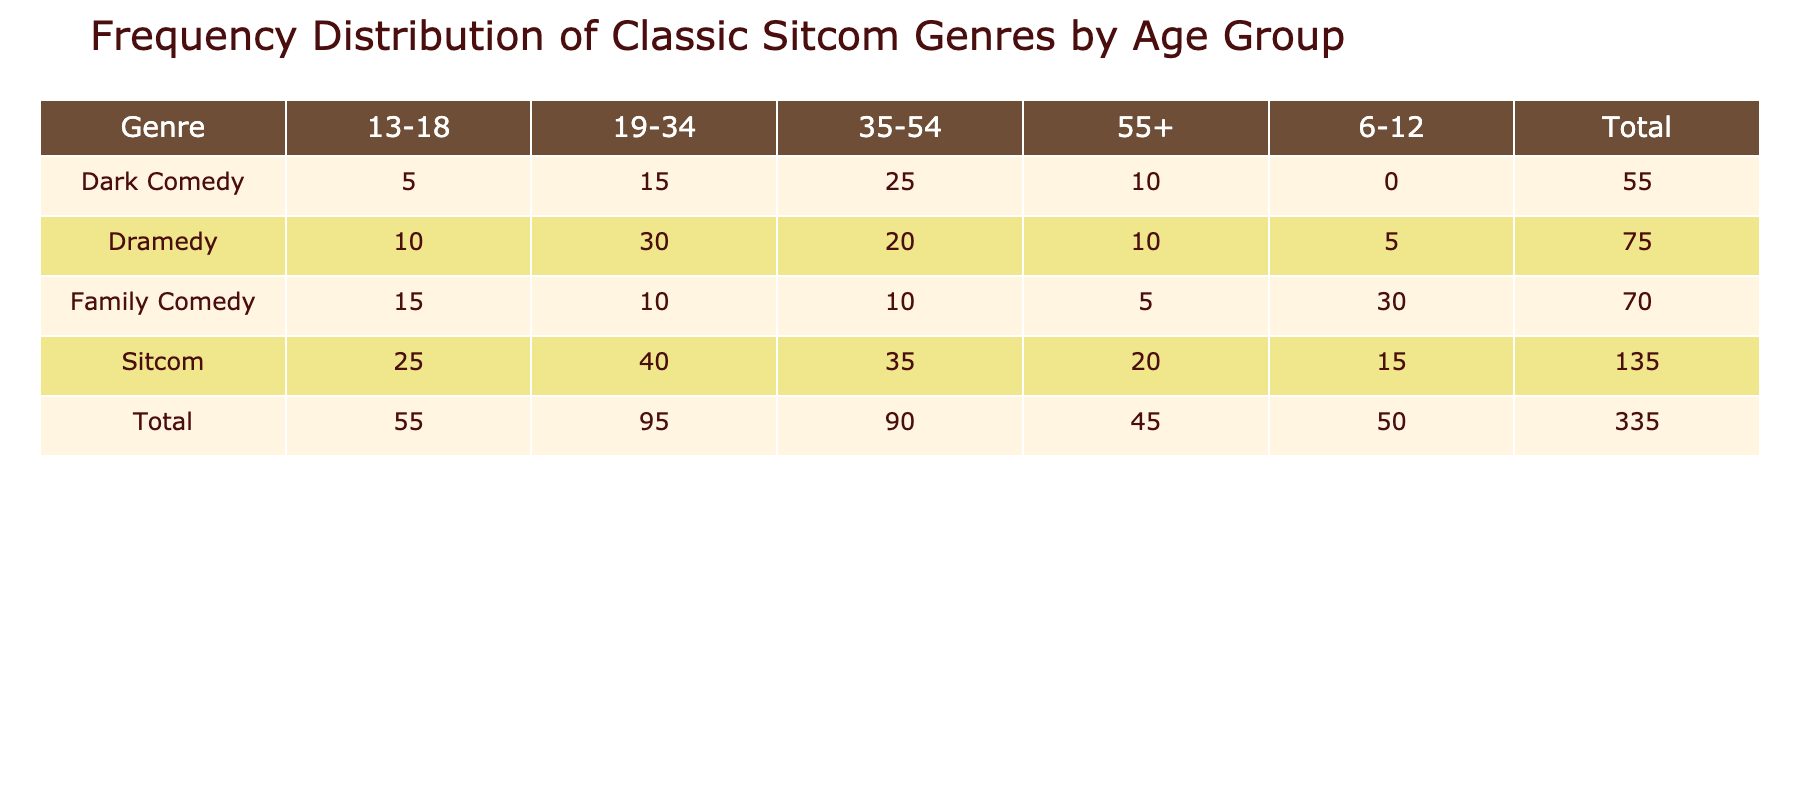What is the total frequency for the genre "Sitcom"? To find the total frequency for the genre "Sitcom", we look at the row corresponding to "Sitcom" and sum the frequencies for all age groups: 15 + 25 + 40 + 35 + 20 = 135.
Answer: 135 Which age group has the highest frequency for "Family Comedy"? By checking the "Family Comedy" row, we see the frequencies: 30 (6-12), 15 (13-18), 10 (19-34), 10 (35-54), and 5 (55+). The highest frequency is 30 in the age group 6-12.
Answer: 6-12 Is there any age group with zero frequency in the "Dark Comedy" genre? Looking at the "Dark Comedy" row, we see the frequency for 6-12 is 0, indicating that no viewers in this age group watch "Dark Comedy". Therefore, the answer is yes.
Answer: Yes What is the average frequency for the genre "Dramedy"? To find the average frequency, we sum the frequencies for "Dramedy": 5 + 10 + 30 + 20 + 10 = 85. There are five age groups, so we divide by 5: 85 / 5 = 17.
Answer: 17 Which age group has the lowest total frequency across all genres? For each age group, we add the frequencies from all genres: 15 + 5 + 30 + 0 = 50 for 6-12; 25 + 10 + 15 + 5 = 55 for 13-18; 40 + 30 + 10 + 15 = 95 for 19-34; 35 + 20 + 10 + 25 = 90 for 35-54; 20 + 10 + 5 + 10 = 55 for 55+. The age group 6-12 has the lowest total frequency of 50.
Answer: 6-12 How many total viewers are there across all age groups for the “Sitcom” genre? To find the total viewers for “Sitcom,” we sum the frequencies from each age group: 15 + 25 + 40 + 35 + 20 = 135, which gives the total number of viewers for this genre.
Answer: 135 